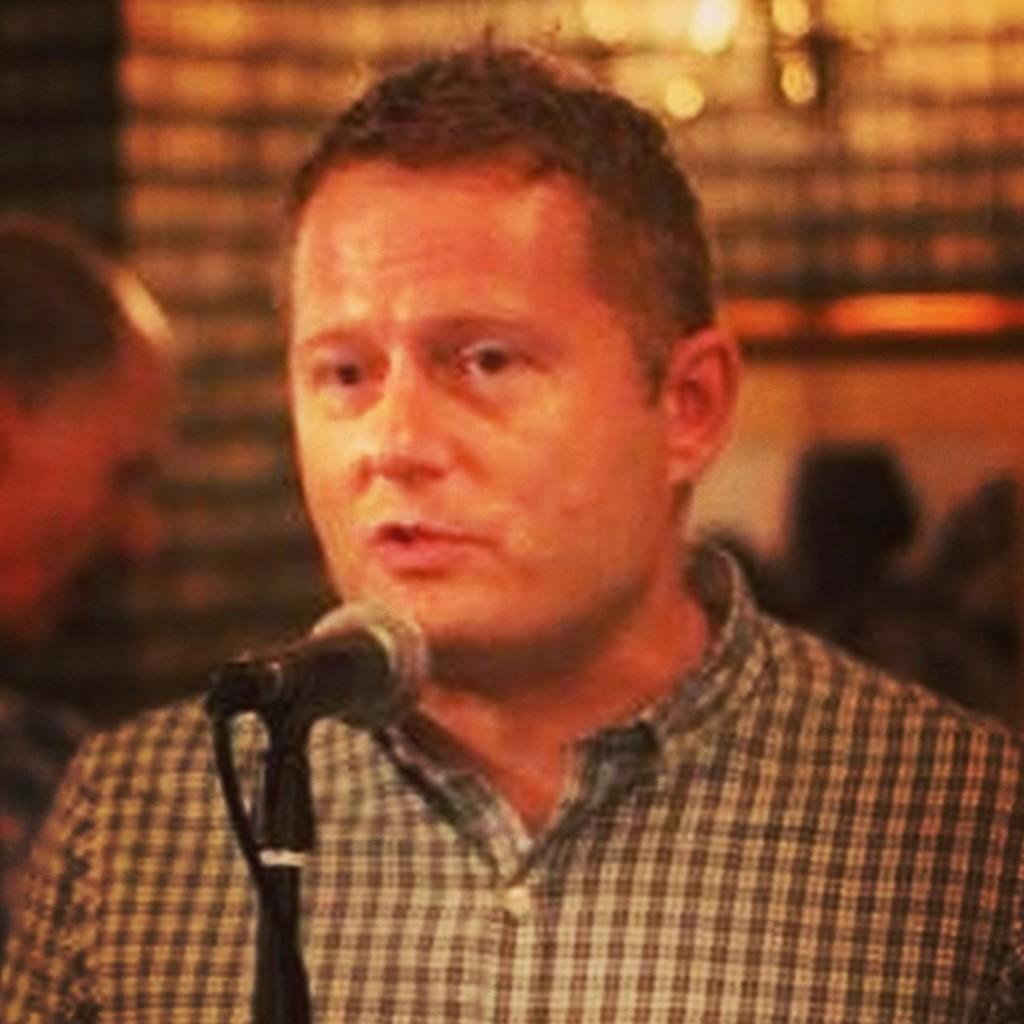What is the main subject of the image? There is a person in the image. What is the person wearing? The person is wearing a shirt. What object is in front of the person? There is a microphone in front of the person. Can you describe the background of the image? There are other persons and objects in the background of the image. What type of joke does the person tell in the image? There is no indication in the image that the person is telling a joke, so it cannot be determined from the picture. 